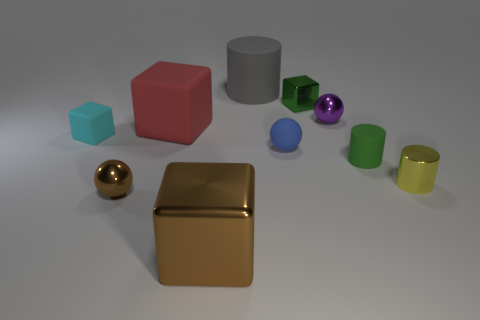Subtract 1 cubes. How many cubes are left? 3 Subtract all purple blocks. Subtract all cyan spheres. How many blocks are left? 4 Subtract all balls. How many objects are left? 7 Add 8 green cubes. How many green cubes exist? 9 Subtract 1 cyan cubes. How many objects are left? 9 Subtract all green rubber spheres. Subtract all metal spheres. How many objects are left? 8 Add 4 red rubber things. How many red rubber things are left? 5 